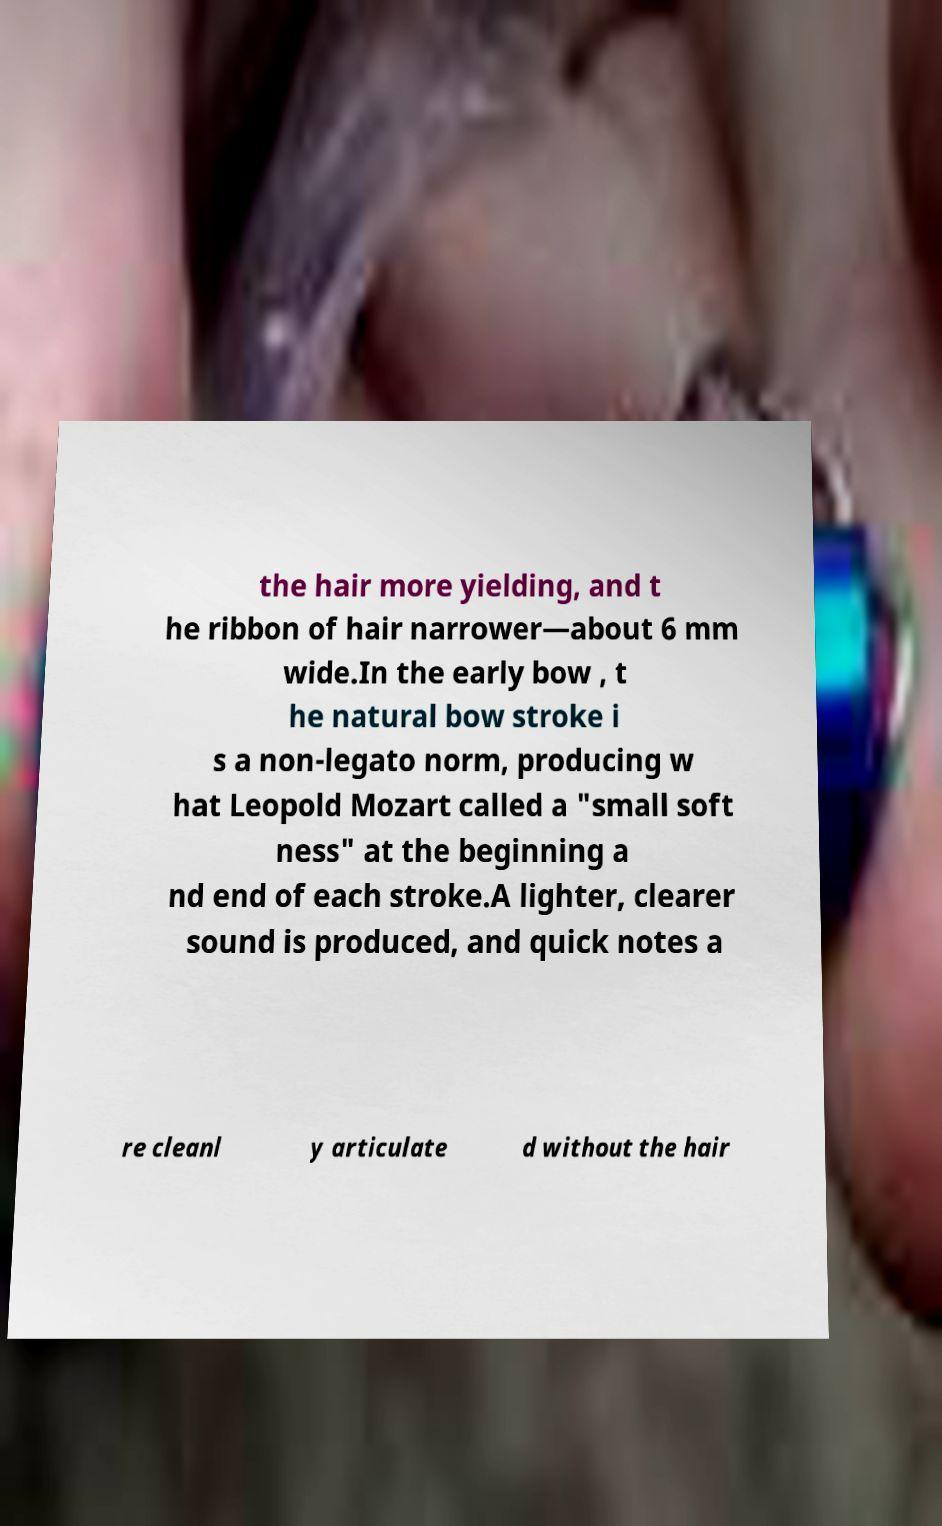Could you assist in decoding the text presented in this image and type it out clearly? the hair more yielding, and t he ribbon of hair narrower—about 6 mm wide.In the early bow , t he natural bow stroke i s a non-legato norm, producing w hat Leopold Mozart called a "small soft ness" at the beginning a nd end of each stroke.A lighter, clearer sound is produced, and quick notes a re cleanl y articulate d without the hair 